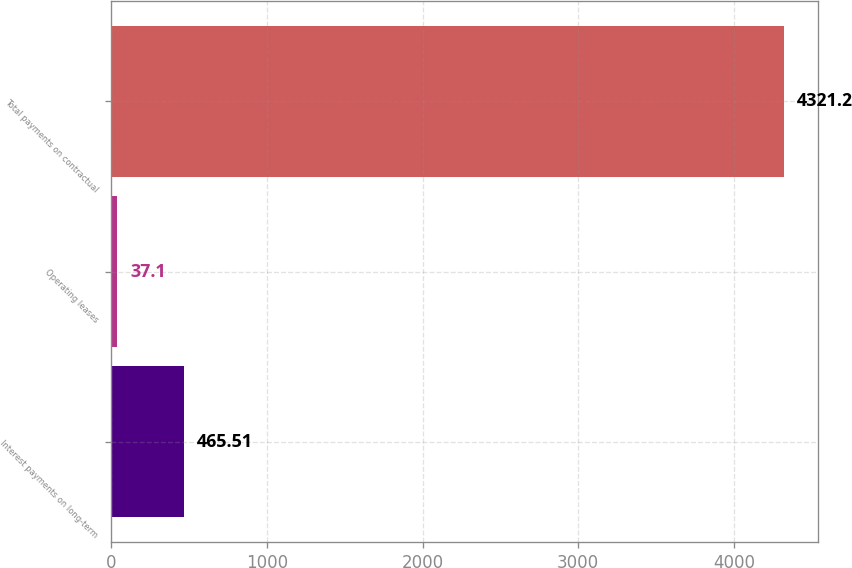Convert chart. <chart><loc_0><loc_0><loc_500><loc_500><bar_chart><fcel>Interest payments on long-term<fcel>Operating leases<fcel>Total payments on contractual<nl><fcel>465.51<fcel>37.1<fcel>4321.2<nl></chart> 